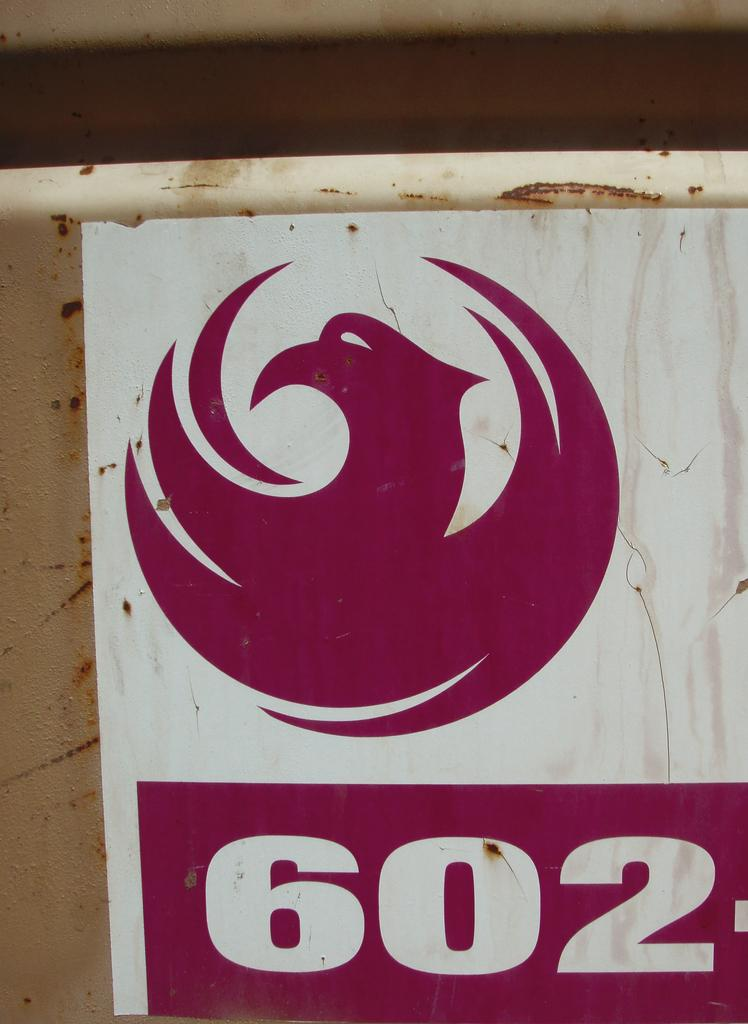Provide a one-sentence caption for the provided image. A sticker of a logo and the numeral "602". 